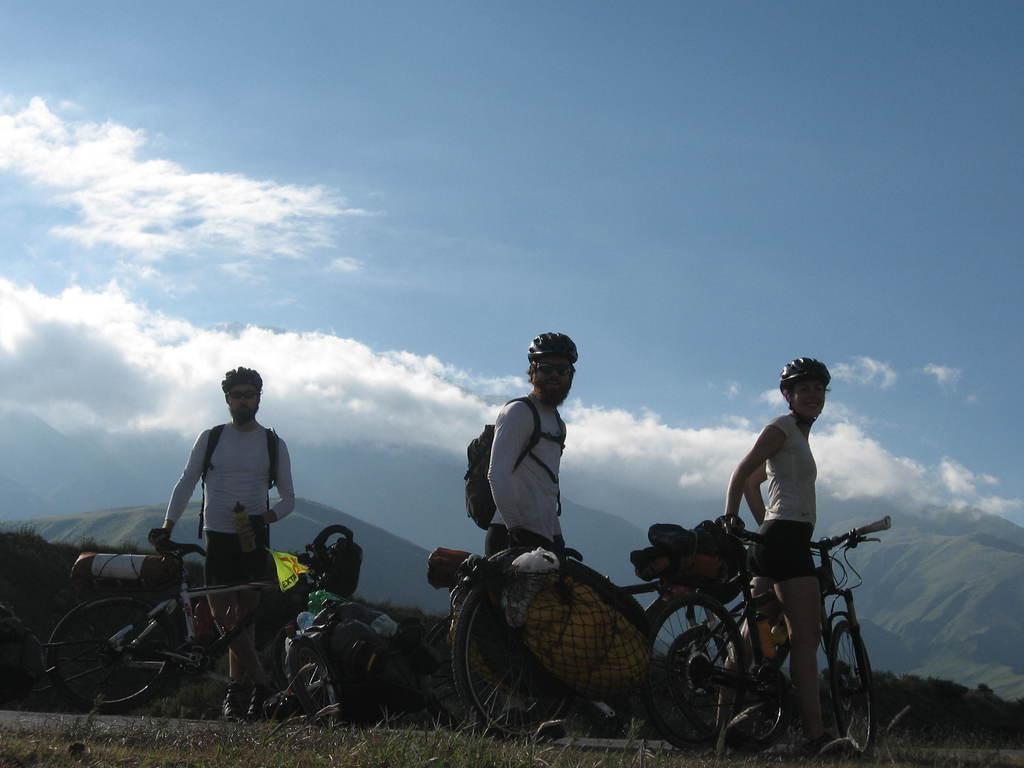Please provide a concise description of this image. Sky is cloudy. These persons are holding a bicycle. This person is holding a bottle and bag. This 3 persons wore helmet. Far there are mountain. 